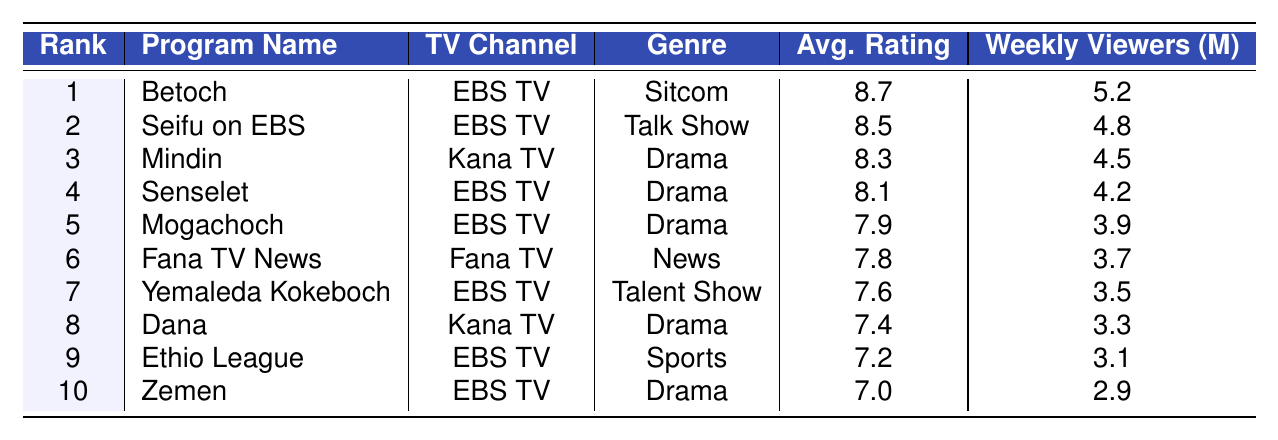What is the average rating of the program "Betoch"? According to the table, the average rating of "Betoch" is listed directly in the corresponding row, which shows an average rating of 8.7.
Answer: 8.7 Which program has the highest number of weekly viewers? The program with the highest number of weekly viewers is "Betoch," which has 5.2 million viewers according to the table data.
Answer: Betoch Is "Mindin" a drama program? Yes, the table categorizes "Mindin" under the Genre column as "Drama."
Answer: Yes What is the average rating of the top three programs? The average rating of the top three programs is calculated as follows: (8.7 + 8.5 + 8.3) / 3 = 8.5.
Answer: 8.5 How many million weekly viewers do "Yemaleda Kokeboch" and "Zemen" have combined? "Yemaleda Kokeboch" has 3.5 million viewers and "Zemen" has 2.9 million viewers. Their combined total is 3.5 + 2.9 = 6.4 million viewers.
Answer: 6.4 million What percentage of viewers does the top-rated program get compared to the viewers of the tenth-ranked program? The viewers of the top-rated program "Betoch" (5.2 million) compared to the viewers of the tenth-ranked program "Zemen" (2.9 million) gives us (5.2 / 2.9) * 100% = 179.31%.
Answer: 179.31% Which channel broadcasts the most programs in the top 10 list? By counting the occurrences of TV Channel names in the table, we find that EBS TV appears most frequently, with 6 programs listed.
Answer: EBS TV What is the difference in average ratings between the highest-rated and the lowest-rated programs? The highest-rated program is "Betoch" with 8.7 average rating, and the lowest-rated program is "Zemen" with 7.0. The difference is 8.7 - 7.0 = 1.7.
Answer: 1.7 Are there any talent shows in the top 10 programs? Yes, "Yemaleda Kokeboch" is listed in the table as a talent show, confirming the presence of this genre in the top 10.
Answer: Yes Which program has the lowest average rating? The program with the lowest average rating in the table is "Zemen," which has an average rating of 7.0.
Answer: Zemen 